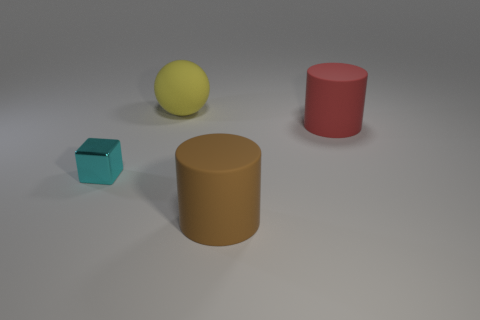Are these objects arranged in any particular pattern? The objects don't appear to follow any specific pattern. They are spaced out randomly across the surface. Could you describe their sizes in relation to each other? Certainly! The blue cube is the smallest object, the yellow ball is slightly larger in diameter but smaller in volume compared to the red cylinder, and the brown cylinder is the largest object both in height and diameter. 